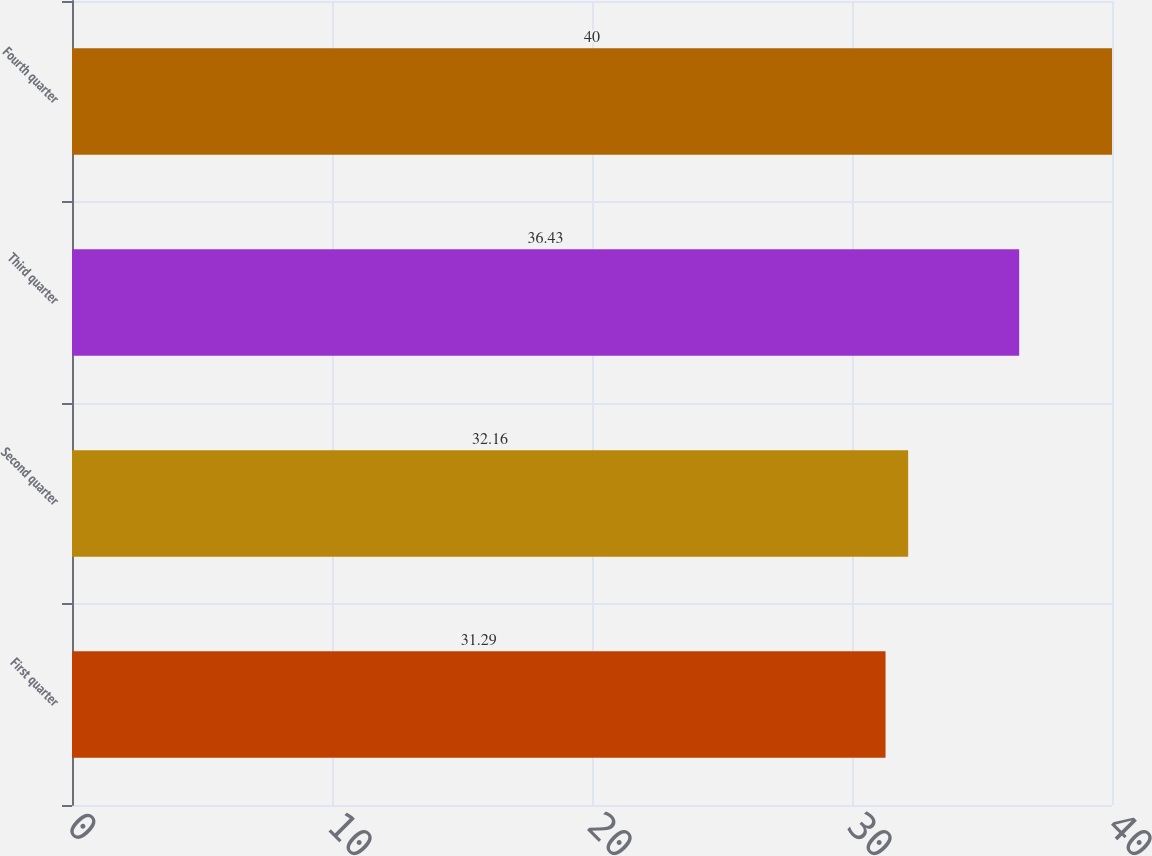Convert chart to OTSL. <chart><loc_0><loc_0><loc_500><loc_500><bar_chart><fcel>First quarter<fcel>Second quarter<fcel>Third quarter<fcel>Fourth quarter<nl><fcel>31.29<fcel>32.16<fcel>36.43<fcel>40<nl></chart> 